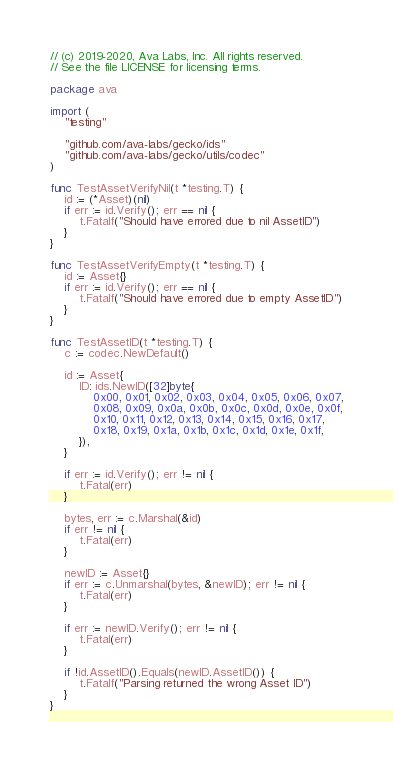Convert code to text. <code><loc_0><loc_0><loc_500><loc_500><_Go_>// (c) 2019-2020, Ava Labs, Inc. All rights reserved.
// See the file LICENSE for licensing terms.

package ava

import (
	"testing"

	"github.com/ava-labs/gecko/ids"
	"github.com/ava-labs/gecko/utils/codec"
)

func TestAssetVerifyNil(t *testing.T) {
	id := (*Asset)(nil)
	if err := id.Verify(); err == nil {
		t.Fatalf("Should have errored due to nil AssetID")
	}
}

func TestAssetVerifyEmpty(t *testing.T) {
	id := Asset{}
	if err := id.Verify(); err == nil {
		t.Fatalf("Should have errored due to empty AssetID")
	}
}

func TestAssetID(t *testing.T) {
	c := codec.NewDefault()

	id := Asset{
		ID: ids.NewID([32]byte{
			0x00, 0x01, 0x02, 0x03, 0x04, 0x05, 0x06, 0x07,
			0x08, 0x09, 0x0a, 0x0b, 0x0c, 0x0d, 0x0e, 0x0f,
			0x10, 0x11, 0x12, 0x13, 0x14, 0x15, 0x16, 0x17,
			0x18, 0x19, 0x1a, 0x1b, 0x1c, 0x1d, 0x1e, 0x1f,
		}),
	}

	if err := id.Verify(); err != nil {
		t.Fatal(err)
	}

	bytes, err := c.Marshal(&id)
	if err != nil {
		t.Fatal(err)
	}

	newID := Asset{}
	if err := c.Unmarshal(bytes, &newID); err != nil {
		t.Fatal(err)
	}

	if err := newID.Verify(); err != nil {
		t.Fatal(err)
	}

	if !id.AssetID().Equals(newID.AssetID()) {
		t.Fatalf("Parsing returned the wrong Asset ID")
	}
}
</code> 